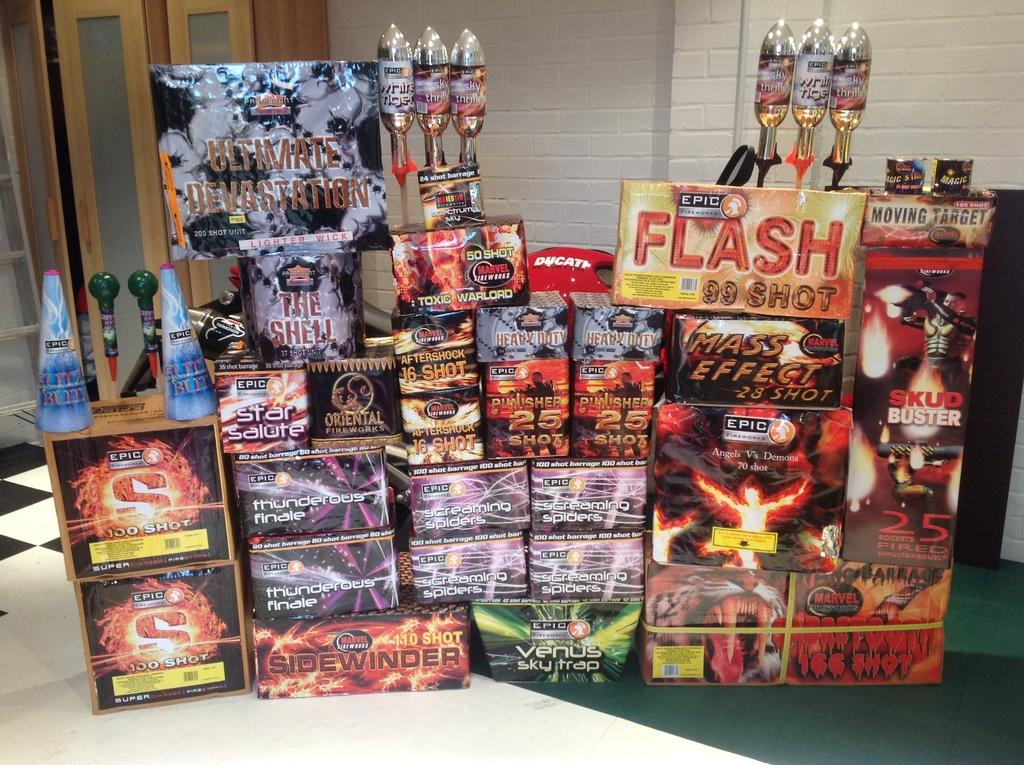<image>
Write a terse but informative summary of the picture. A firework display sits on a floor with one being called thunderous finale 